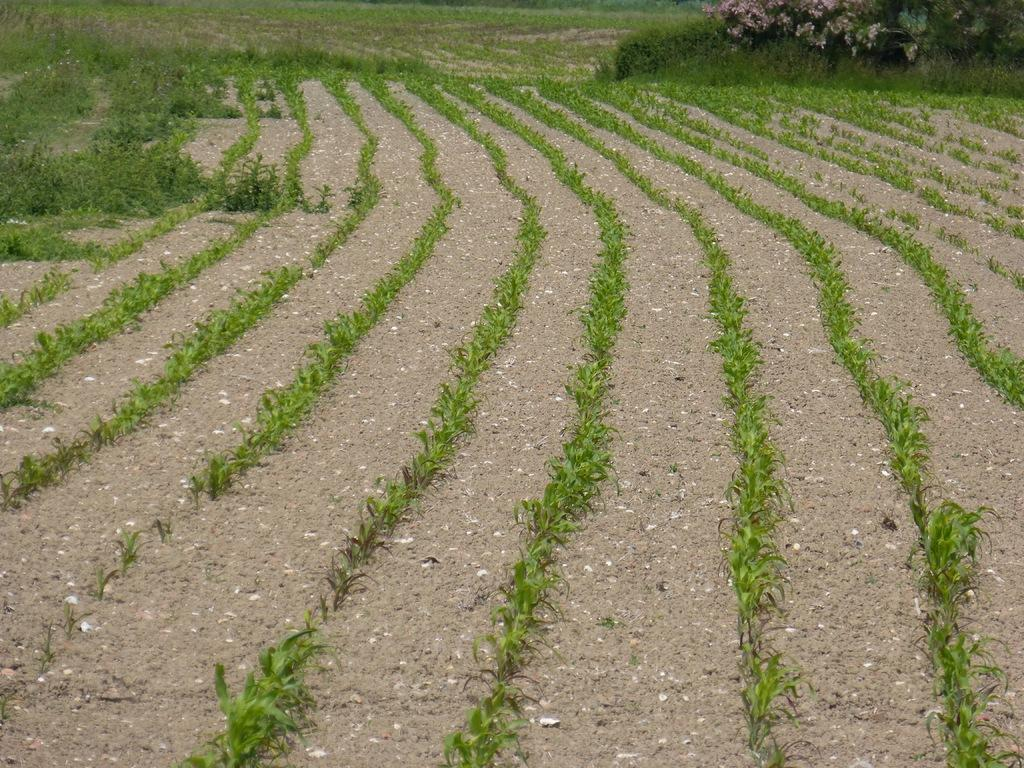What type of surface can be seen in the image? The ground is visible in the image. What type of vegetation is present in the image? There is grass in the image. What other types of plants can be seen in the image? There are plants in the image. What type of leather is being used to create the island in the image? There is no leather or island present in the image. What type of operation is being performed on the plants in the image? There is no operation being performed on the plants in the image; they are simply visible. 